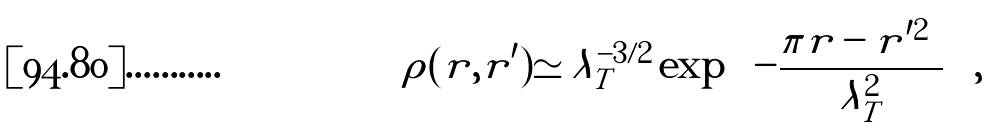Convert formula to latex. <formula><loc_0><loc_0><loc_500><loc_500>\rho ( { r } , { r ^ { \prime } } ) \simeq \lambda _ { T } ^ { - 3 / 2 } \exp \left ( - \frac { \pi | { r } - { r ^ { \prime } } | ^ { 2 } } { \lambda _ { T } ^ { 2 } } \right ) ,</formula> 